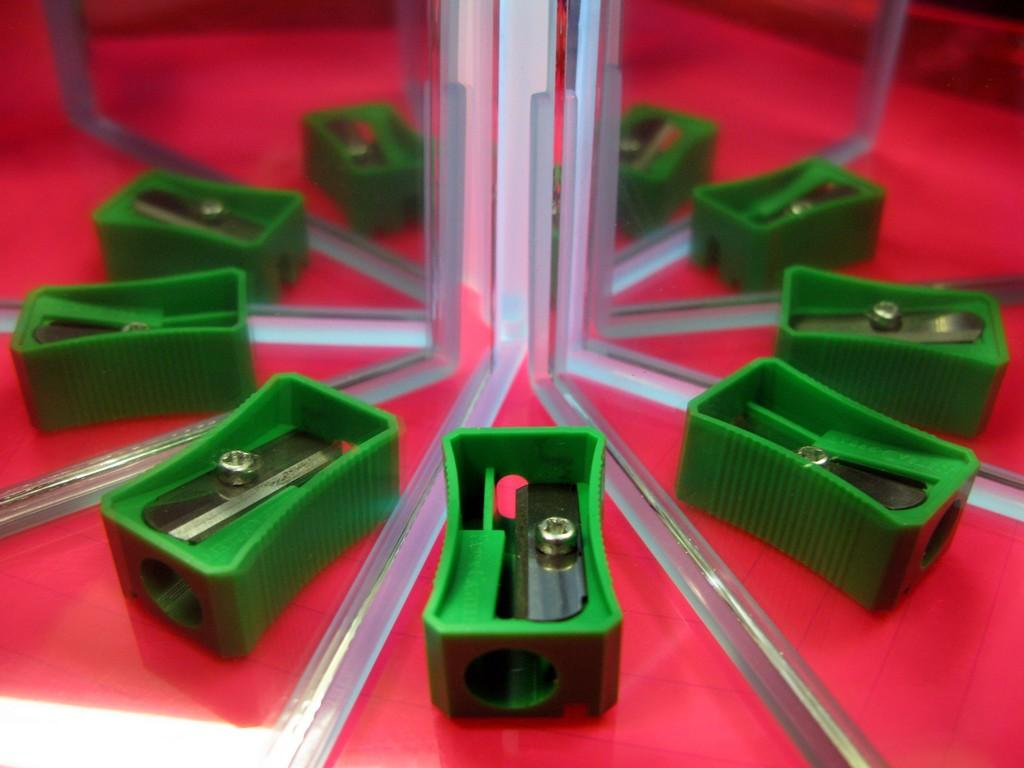What color is the sharpener in the image? The sharpener in the image is green. How many mirrors are present in the image? There are two mirrors in the image. What do the mirrors reflect in the image? The mirrors reflect the sharpener in the image. Do the mirrors reflect each other in the image? Yes, one mirror reflects the other mirror in the image. What type of paint is being used on the station in the image? There is no station or paint present in the image; it features a green-colored sharpener and two mirrors. 